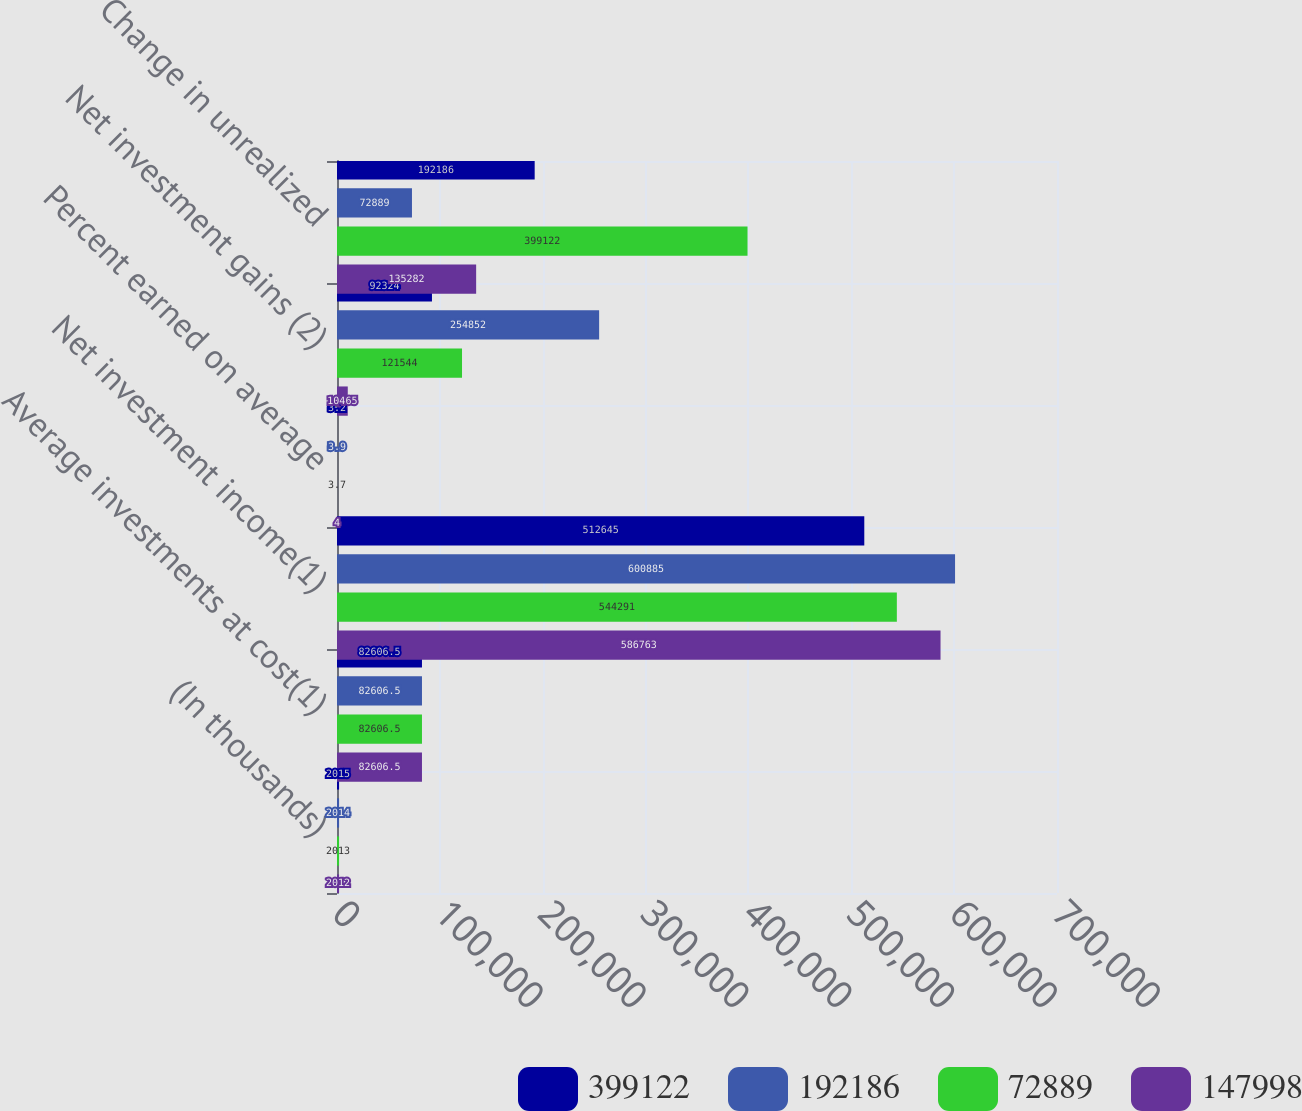Convert chart. <chart><loc_0><loc_0><loc_500><loc_500><stacked_bar_chart><ecel><fcel>(In thousands)<fcel>Average investments at cost(1)<fcel>Net investment income(1)<fcel>Percent earned on average<fcel>Net investment gains (2)<fcel>Change in unrealized<nl><fcel>399122<fcel>2015<fcel>82606.5<fcel>512645<fcel>3.2<fcel>92324<fcel>192186<nl><fcel>192186<fcel>2014<fcel>82606.5<fcel>600885<fcel>3.9<fcel>254852<fcel>72889<nl><fcel>72889<fcel>2013<fcel>82606.5<fcel>544291<fcel>3.7<fcel>121544<fcel>399122<nl><fcel>147998<fcel>2012<fcel>82606.5<fcel>586763<fcel>4<fcel>10465<fcel>135282<nl></chart> 